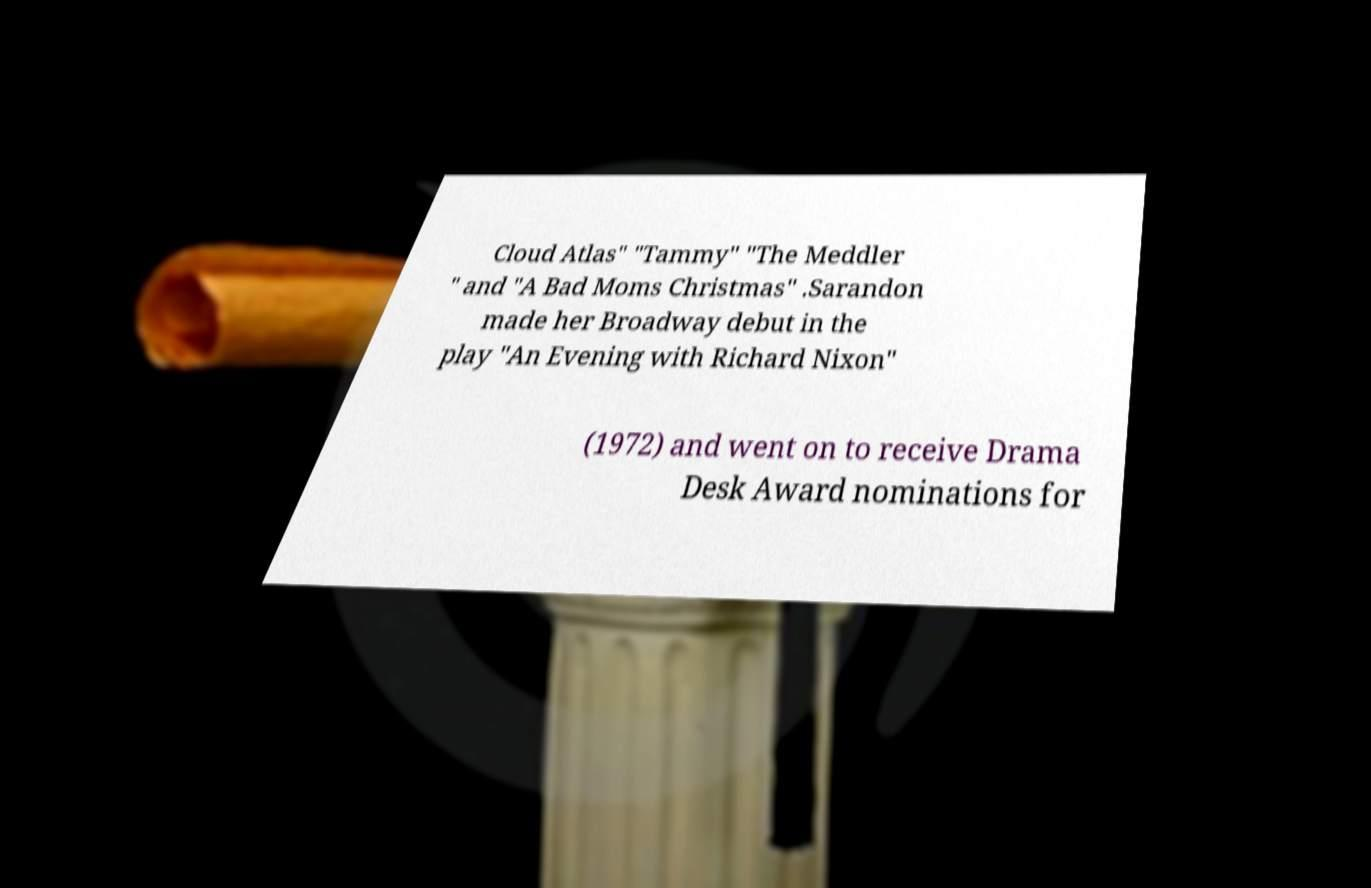I need the written content from this picture converted into text. Can you do that? Cloud Atlas" "Tammy" "The Meddler " and "A Bad Moms Christmas" .Sarandon made her Broadway debut in the play "An Evening with Richard Nixon" (1972) and went on to receive Drama Desk Award nominations for 